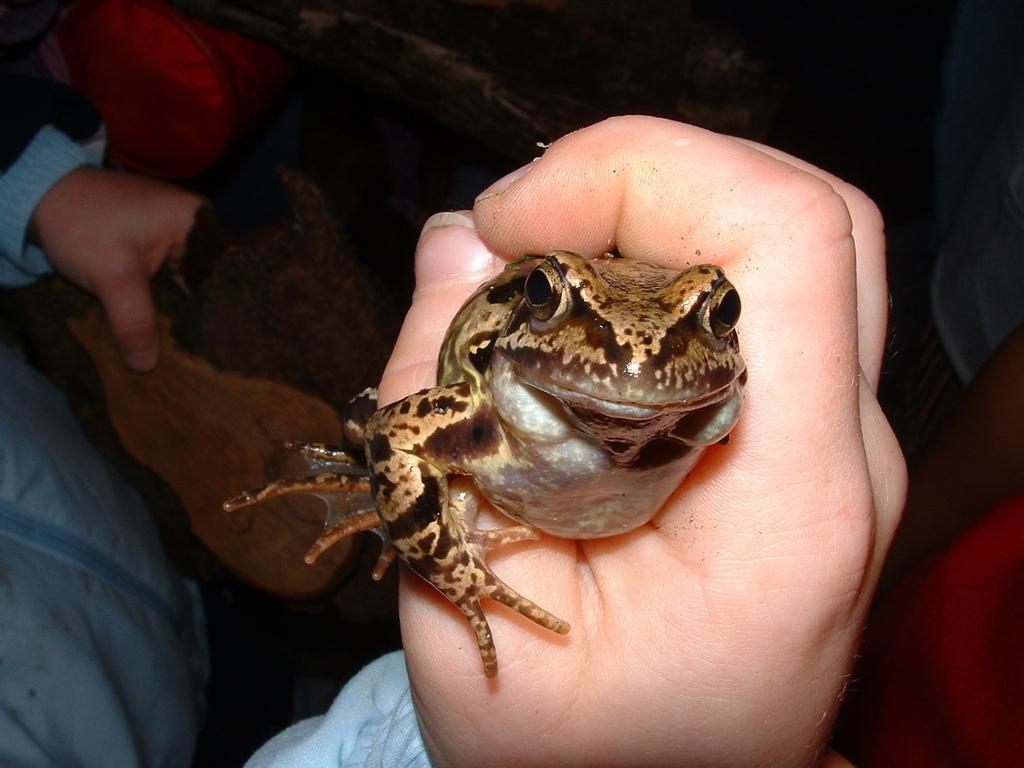In one or two sentences, can you explain what this image depicts? In the image there is a person holding a frog, he is wearing blue jacket. 